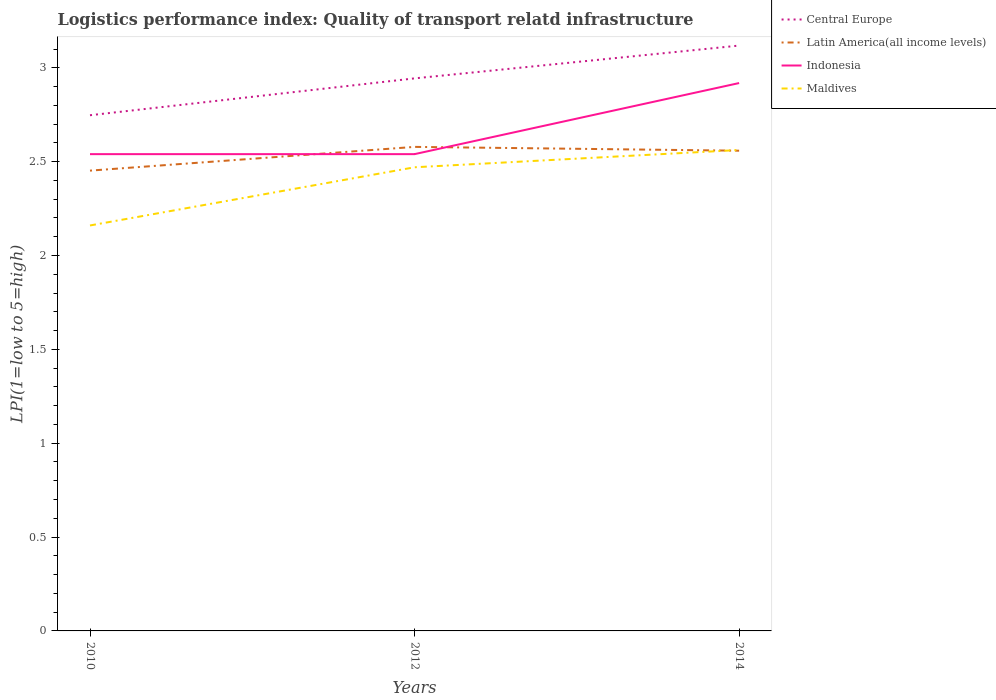How many different coloured lines are there?
Ensure brevity in your answer.  4. Is the number of lines equal to the number of legend labels?
Keep it short and to the point. Yes. Across all years, what is the maximum logistics performance index in Indonesia?
Offer a terse response. 2.54. In which year was the logistics performance index in Central Europe maximum?
Keep it short and to the point. 2010. What is the total logistics performance index in Maldives in the graph?
Offer a very short reply. -0.31. What is the difference between the highest and the second highest logistics performance index in Central Europe?
Provide a short and direct response. 0.37. What is the difference between the highest and the lowest logistics performance index in Maldives?
Offer a terse response. 2. How many lines are there?
Your response must be concise. 4. How many years are there in the graph?
Provide a short and direct response. 3. What is the difference between two consecutive major ticks on the Y-axis?
Keep it short and to the point. 0.5. Does the graph contain any zero values?
Your answer should be compact. No. How many legend labels are there?
Give a very brief answer. 4. What is the title of the graph?
Provide a succinct answer. Logistics performance index: Quality of transport relatd infrastructure. What is the label or title of the X-axis?
Make the answer very short. Years. What is the label or title of the Y-axis?
Provide a short and direct response. LPI(1=low to 5=high). What is the LPI(1=low to 5=high) of Central Europe in 2010?
Make the answer very short. 2.75. What is the LPI(1=low to 5=high) of Latin America(all income levels) in 2010?
Your answer should be very brief. 2.45. What is the LPI(1=low to 5=high) of Indonesia in 2010?
Your answer should be compact. 2.54. What is the LPI(1=low to 5=high) in Maldives in 2010?
Offer a very short reply. 2.16. What is the LPI(1=low to 5=high) in Central Europe in 2012?
Provide a short and direct response. 2.94. What is the LPI(1=low to 5=high) in Latin America(all income levels) in 2012?
Offer a very short reply. 2.58. What is the LPI(1=low to 5=high) of Indonesia in 2012?
Your response must be concise. 2.54. What is the LPI(1=low to 5=high) in Maldives in 2012?
Ensure brevity in your answer.  2.47. What is the LPI(1=low to 5=high) in Central Europe in 2014?
Make the answer very short. 3.12. What is the LPI(1=low to 5=high) in Latin America(all income levels) in 2014?
Offer a very short reply. 2.56. What is the LPI(1=low to 5=high) of Indonesia in 2014?
Your response must be concise. 2.92. What is the LPI(1=low to 5=high) in Maldives in 2014?
Provide a short and direct response. 2.56. Across all years, what is the maximum LPI(1=low to 5=high) of Central Europe?
Your answer should be very brief. 3.12. Across all years, what is the maximum LPI(1=low to 5=high) in Latin America(all income levels)?
Provide a succinct answer. 2.58. Across all years, what is the maximum LPI(1=low to 5=high) in Indonesia?
Offer a terse response. 2.92. Across all years, what is the maximum LPI(1=low to 5=high) of Maldives?
Make the answer very short. 2.56. Across all years, what is the minimum LPI(1=low to 5=high) of Central Europe?
Your response must be concise. 2.75. Across all years, what is the minimum LPI(1=low to 5=high) in Latin America(all income levels)?
Your answer should be compact. 2.45. Across all years, what is the minimum LPI(1=low to 5=high) in Indonesia?
Offer a terse response. 2.54. Across all years, what is the minimum LPI(1=low to 5=high) of Maldives?
Make the answer very short. 2.16. What is the total LPI(1=low to 5=high) in Central Europe in the graph?
Give a very brief answer. 8.81. What is the total LPI(1=low to 5=high) of Latin America(all income levels) in the graph?
Your answer should be compact. 7.59. What is the total LPI(1=low to 5=high) of Indonesia in the graph?
Make the answer very short. 8. What is the total LPI(1=low to 5=high) in Maldives in the graph?
Offer a very short reply. 7.19. What is the difference between the LPI(1=low to 5=high) in Central Europe in 2010 and that in 2012?
Ensure brevity in your answer.  -0.2. What is the difference between the LPI(1=low to 5=high) in Latin America(all income levels) in 2010 and that in 2012?
Offer a very short reply. -0.13. What is the difference between the LPI(1=low to 5=high) of Maldives in 2010 and that in 2012?
Offer a terse response. -0.31. What is the difference between the LPI(1=low to 5=high) in Central Europe in 2010 and that in 2014?
Offer a very short reply. -0.37. What is the difference between the LPI(1=low to 5=high) in Latin America(all income levels) in 2010 and that in 2014?
Provide a succinct answer. -0.11. What is the difference between the LPI(1=low to 5=high) in Indonesia in 2010 and that in 2014?
Provide a short and direct response. -0.38. What is the difference between the LPI(1=low to 5=high) in Maldives in 2010 and that in 2014?
Give a very brief answer. -0.4. What is the difference between the LPI(1=low to 5=high) in Central Europe in 2012 and that in 2014?
Provide a succinct answer. -0.17. What is the difference between the LPI(1=low to 5=high) in Latin America(all income levels) in 2012 and that in 2014?
Your answer should be very brief. 0.02. What is the difference between the LPI(1=low to 5=high) of Indonesia in 2012 and that in 2014?
Offer a very short reply. -0.38. What is the difference between the LPI(1=low to 5=high) of Maldives in 2012 and that in 2014?
Your answer should be very brief. -0.09. What is the difference between the LPI(1=low to 5=high) in Central Europe in 2010 and the LPI(1=low to 5=high) in Latin America(all income levels) in 2012?
Your answer should be compact. 0.17. What is the difference between the LPI(1=low to 5=high) in Central Europe in 2010 and the LPI(1=low to 5=high) in Indonesia in 2012?
Give a very brief answer. 0.21. What is the difference between the LPI(1=low to 5=high) in Central Europe in 2010 and the LPI(1=low to 5=high) in Maldives in 2012?
Provide a short and direct response. 0.28. What is the difference between the LPI(1=low to 5=high) in Latin America(all income levels) in 2010 and the LPI(1=low to 5=high) in Indonesia in 2012?
Ensure brevity in your answer.  -0.09. What is the difference between the LPI(1=low to 5=high) in Latin America(all income levels) in 2010 and the LPI(1=low to 5=high) in Maldives in 2012?
Offer a terse response. -0.02. What is the difference between the LPI(1=low to 5=high) in Indonesia in 2010 and the LPI(1=low to 5=high) in Maldives in 2012?
Give a very brief answer. 0.07. What is the difference between the LPI(1=low to 5=high) in Central Europe in 2010 and the LPI(1=low to 5=high) in Latin America(all income levels) in 2014?
Make the answer very short. 0.19. What is the difference between the LPI(1=low to 5=high) of Central Europe in 2010 and the LPI(1=low to 5=high) of Indonesia in 2014?
Offer a terse response. -0.17. What is the difference between the LPI(1=low to 5=high) of Central Europe in 2010 and the LPI(1=low to 5=high) of Maldives in 2014?
Keep it short and to the point. 0.19. What is the difference between the LPI(1=low to 5=high) in Latin America(all income levels) in 2010 and the LPI(1=low to 5=high) in Indonesia in 2014?
Make the answer very short. -0.47. What is the difference between the LPI(1=low to 5=high) in Latin America(all income levels) in 2010 and the LPI(1=low to 5=high) in Maldives in 2014?
Offer a very short reply. -0.11. What is the difference between the LPI(1=low to 5=high) of Indonesia in 2010 and the LPI(1=low to 5=high) of Maldives in 2014?
Provide a short and direct response. -0.02. What is the difference between the LPI(1=low to 5=high) of Central Europe in 2012 and the LPI(1=low to 5=high) of Latin America(all income levels) in 2014?
Keep it short and to the point. 0.39. What is the difference between the LPI(1=low to 5=high) of Central Europe in 2012 and the LPI(1=low to 5=high) of Indonesia in 2014?
Ensure brevity in your answer.  0.02. What is the difference between the LPI(1=low to 5=high) of Central Europe in 2012 and the LPI(1=low to 5=high) of Maldives in 2014?
Ensure brevity in your answer.  0.38. What is the difference between the LPI(1=low to 5=high) of Latin America(all income levels) in 2012 and the LPI(1=low to 5=high) of Indonesia in 2014?
Offer a terse response. -0.34. What is the difference between the LPI(1=low to 5=high) in Latin America(all income levels) in 2012 and the LPI(1=low to 5=high) in Maldives in 2014?
Provide a short and direct response. 0.02. What is the difference between the LPI(1=low to 5=high) of Indonesia in 2012 and the LPI(1=low to 5=high) of Maldives in 2014?
Your answer should be very brief. -0.02. What is the average LPI(1=low to 5=high) of Central Europe per year?
Keep it short and to the point. 2.94. What is the average LPI(1=low to 5=high) of Latin America(all income levels) per year?
Make the answer very short. 2.53. What is the average LPI(1=low to 5=high) of Indonesia per year?
Provide a short and direct response. 2.67. What is the average LPI(1=low to 5=high) of Maldives per year?
Your answer should be compact. 2.4. In the year 2010, what is the difference between the LPI(1=low to 5=high) of Central Europe and LPI(1=low to 5=high) of Latin America(all income levels)?
Offer a terse response. 0.3. In the year 2010, what is the difference between the LPI(1=low to 5=high) in Central Europe and LPI(1=low to 5=high) in Indonesia?
Your answer should be very brief. 0.21. In the year 2010, what is the difference between the LPI(1=low to 5=high) of Central Europe and LPI(1=low to 5=high) of Maldives?
Provide a short and direct response. 0.59. In the year 2010, what is the difference between the LPI(1=low to 5=high) of Latin America(all income levels) and LPI(1=low to 5=high) of Indonesia?
Your answer should be compact. -0.09. In the year 2010, what is the difference between the LPI(1=low to 5=high) in Latin America(all income levels) and LPI(1=low to 5=high) in Maldives?
Ensure brevity in your answer.  0.29. In the year 2010, what is the difference between the LPI(1=low to 5=high) of Indonesia and LPI(1=low to 5=high) of Maldives?
Keep it short and to the point. 0.38. In the year 2012, what is the difference between the LPI(1=low to 5=high) in Central Europe and LPI(1=low to 5=high) in Latin America(all income levels)?
Offer a very short reply. 0.36. In the year 2012, what is the difference between the LPI(1=low to 5=high) of Central Europe and LPI(1=low to 5=high) of Indonesia?
Offer a terse response. 0.4. In the year 2012, what is the difference between the LPI(1=low to 5=high) in Central Europe and LPI(1=low to 5=high) in Maldives?
Offer a very short reply. 0.47. In the year 2012, what is the difference between the LPI(1=low to 5=high) in Latin America(all income levels) and LPI(1=low to 5=high) in Indonesia?
Provide a succinct answer. 0.04. In the year 2012, what is the difference between the LPI(1=low to 5=high) in Latin America(all income levels) and LPI(1=low to 5=high) in Maldives?
Your answer should be compact. 0.11. In the year 2012, what is the difference between the LPI(1=low to 5=high) in Indonesia and LPI(1=low to 5=high) in Maldives?
Provide a short and direct response. 0.07. In the year 2014, what is the difference between the LPI(1=low to 5=high) of Central Europe and LPI(1=low to 5=high) of Latin America(all income levels)?
Your answer should be compact. 0.56. In the year 2014, what is the difference between the LPI(1=low to 5=high) of Central Europe and LPI(1=low to 5=high) of Indonesia?
Provide a short and direct response. 0.2. In the year 2014, what is the difference between the LPI(1=low to 5=high) in Central Europe and LPI(1=low to 5=high) in Maldives?
Offer a very short reply. 0.56. In the year 2014, what is the difference between the LPI(1=low to 5=high) of Latin America(all income levels) and LPI(1=low to 5=high) of Indonesia?
Your answer should be compact. -0.36. In the year 2014, what is the difference between the LPI(1=low to 5=high) in Latin America(all income levels) and LPI(1=low to 5=high) in Maldives?
Make the answer very short. -0. In the year 2014, what is the difference between the LPI(1=low to 5=high) in Indonesia and LPI(1=low to 5=high) in Maldives?
Keep it short and to the point. 0.36. What is the ratio of the LPI(1=low to 5=high) of Central Europe in 2010 to that in 2012?
Offer a very short reply. 0.93. What is the ratio of the LPI(1=low to 5=high) in Latin America(all income levels) in 2010 to that in 2012?
Keep it short and to the point. 0.95. What is the ratio of the LPI(1=low to 5=high) of Indonesia in 2010 to that in 2012?
Offer a very short reply. 1. What is the ratio of the LPI(1=low to 5=high) in Maldives in 2010 to that in 2012?
Provide a succinct answer. 0.87. What is the ratio of the LPI(1=low to 5=high) in Central Europe in 2010 to that in 2014?
Provide a succinct answer. 0.88. What is the ratio of the LPI(1=low to 5=high) in Latin America(all income levels) in 2010 to that in 2014?
Offer a very short reply. 0.96. What is the ratio of the LPI(1=low to 5=high) of Indonesia in 2010 to that in 2014?
Your answer should be very brief. 0.87. What is the ratio of the LPI(1=low to 5=high) in Maldives in 2010 to that in 2014?
Your answer should be compact. 0.84. What is the ratio of the LPI(1=low to 5=high) in Central Europe in 2012 to that in 2014?
Ensure brevity in your answer.  0.94. What is the ratio of the LPI(1=low to 5=high) of Latin America(all income levels) in 2012 to that in 2014?
Your response must be concise. 1.01. What is the ratio of the LPI(1=low to 5=high) of Indonesia in 2012 to that in 2014?
Offer a terse response. 0.87. What is the difference between the highest and the second highest LPI(1=low to 5=high) in Central Europe?
Your answer should be very brief. 0.17. What is the difference between the highest and the second highest LPI(1=low to 5=high) in Latin America(all income levels)?
Provide a short and direct response. 0.02. What is the difference between the highest and the second highest LPI(1=low to 5=high) of Indonesia?
Your answer should be compact. 0.38. What is the difference between the highest and the second highest LPI(1=low to 5=high) of Maldives?
Make the answer very short. 0.09. What is the difference between the highest and the lowest LPI(1=low to 5=high) in Central Europe?
Your answer should be very brief. 0.37. What is the difference between the highest and the lowest LPI(1=low to 5=high) in Latin America(all income levels)?
Offer a very short reply. 0.13. What is the difference between the highest and the lowest LPI(1=low to 5=high) of Indonesia?
Keep it short and to the point. 0.38. What is the difference between the highest and the lowest LPI(1=low to 5=high) of Maldives?
Your answer should be compact. 0.4. 